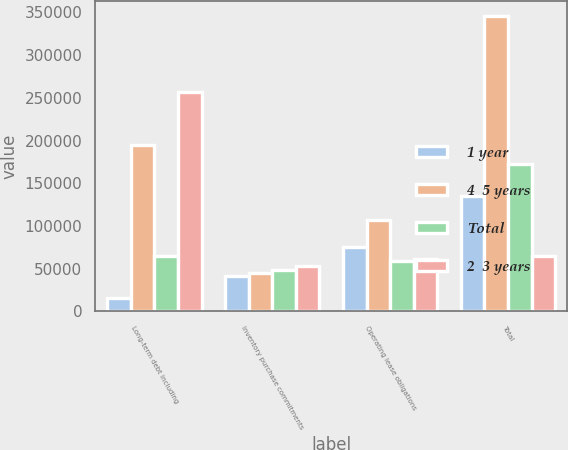Convert chart to OTSL. <chart><loc_0><loc_0><loc_500><loc_500><stacked_bar_chart><ecel><fcel>Long-term debt including<fcel>Inventory purchase commitments<fcel>Operating lease obligations<fcel>Total<nl><fcel>1 year<fcel>15654<fcel>41920<fcel>75394<fcel>135380<nl><fcel>4  5 years<fcel>194421<fcel>44533<fcel>106392<fcel>346102<nl><fcel>Total<fcel>65240<fcel>48339<fcel>58866<fcel>172480<nl><fcel>2  3 years<fcel>256405<fcel>53294<fcel>61680<fcel>65240<nl></chart> 